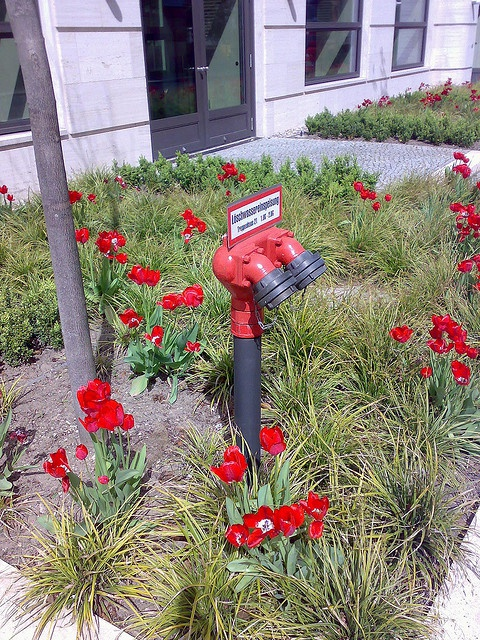Describe the objects in this image and their specific colors. I can see a fire hydrant in black, gray, salmon, and lavender tones in this image. 